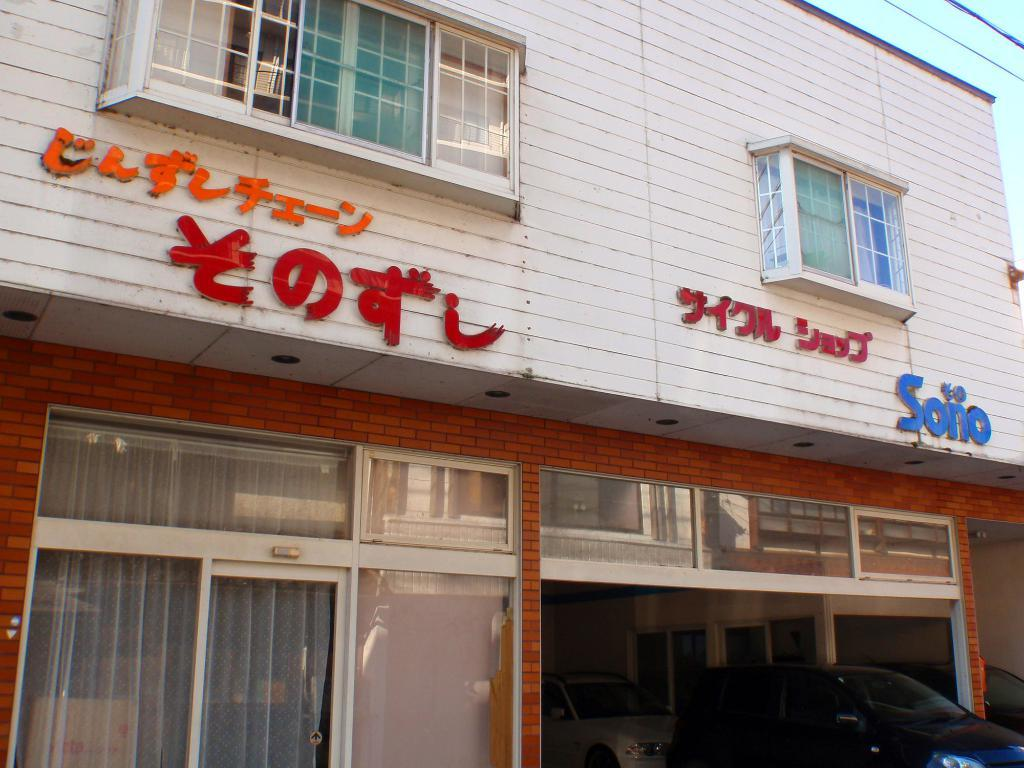What type of establishment does the image appear to depict? The image appears to depict a store. What architectural feature can be seen on the building? There are windows on the building. How many cars are visible in the image? There are 2 cars visible in the image. Can you tell me where the crib is located in the image? There is no crib present in the image. What type of material is the quartz used for in the image? There is no quartz present in the image. 